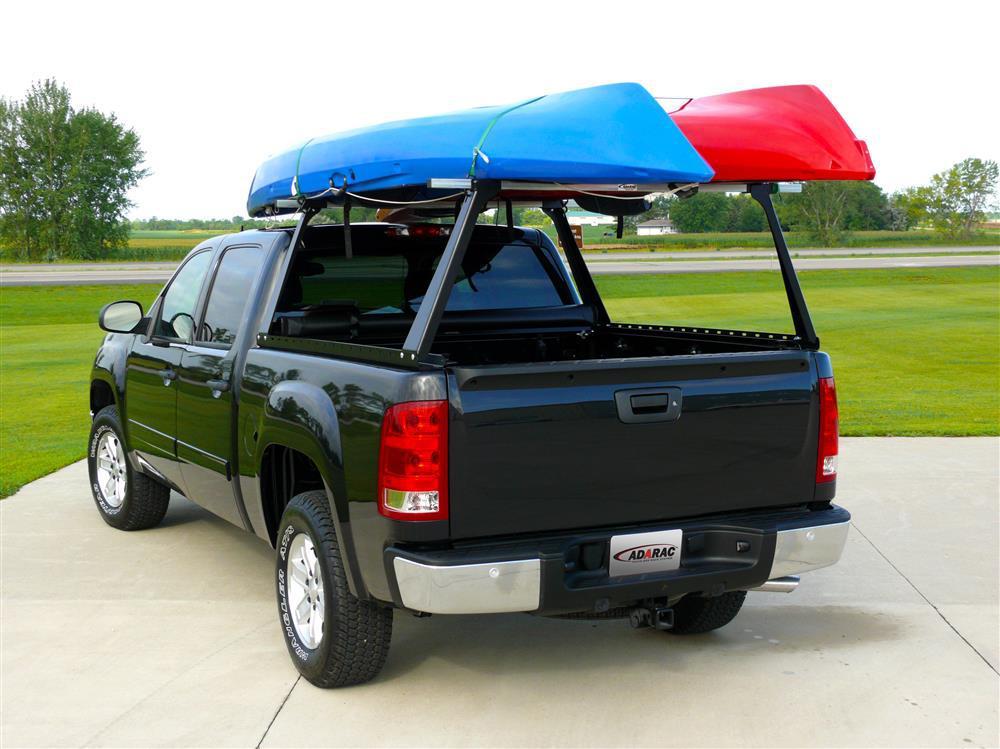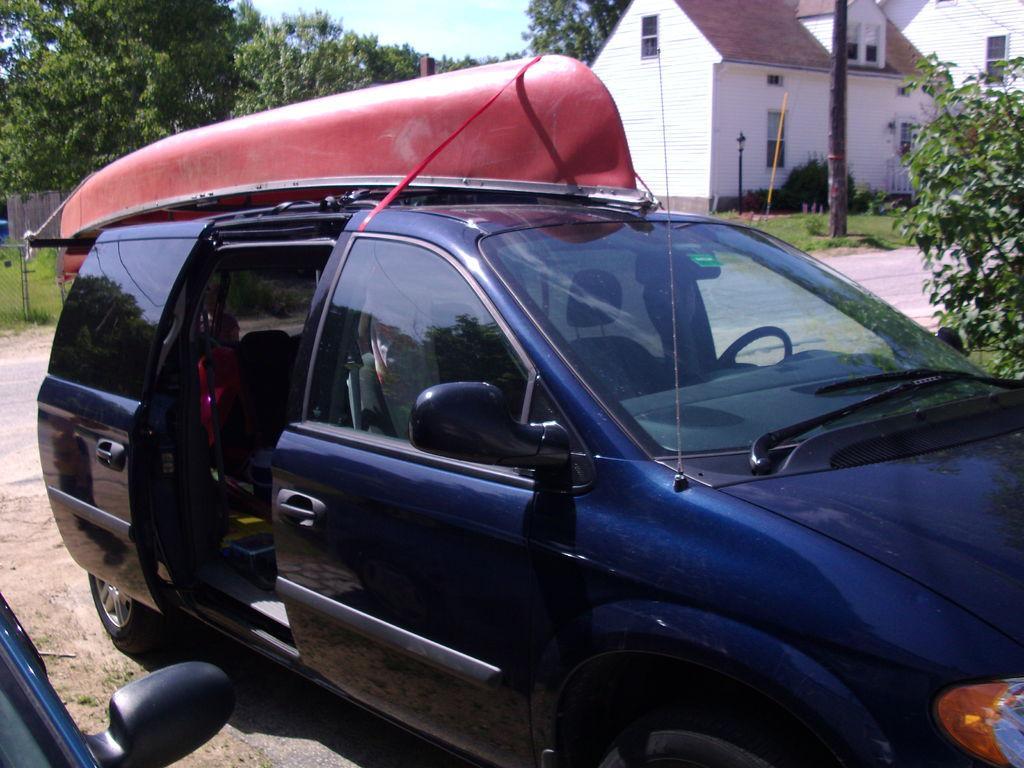The first image is the image on the left, the second image is the image on the right. Considering the images on both sides, is "In one image, a pickup truck has two different-colored boats loaded on an overhead rack." valid? Answer yes or no. Yes. 